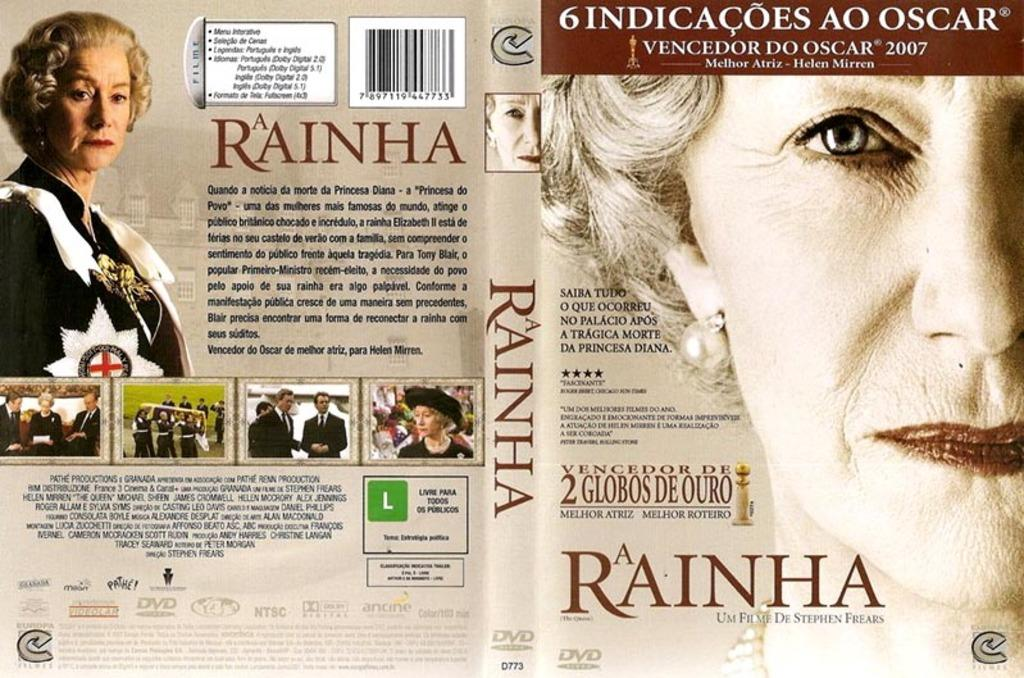What is depicted on the poster in the image? The poster contains alphabets, numbers, and photos. What types of elements are featured on the poster? The poster contains alphabets, numbers, and photos. Where is the woman located in the image? The woman is in the top left corner of the image. What type of plants can be seen growing on the woman's watch in the image? There is no watch or plants present in the image. 